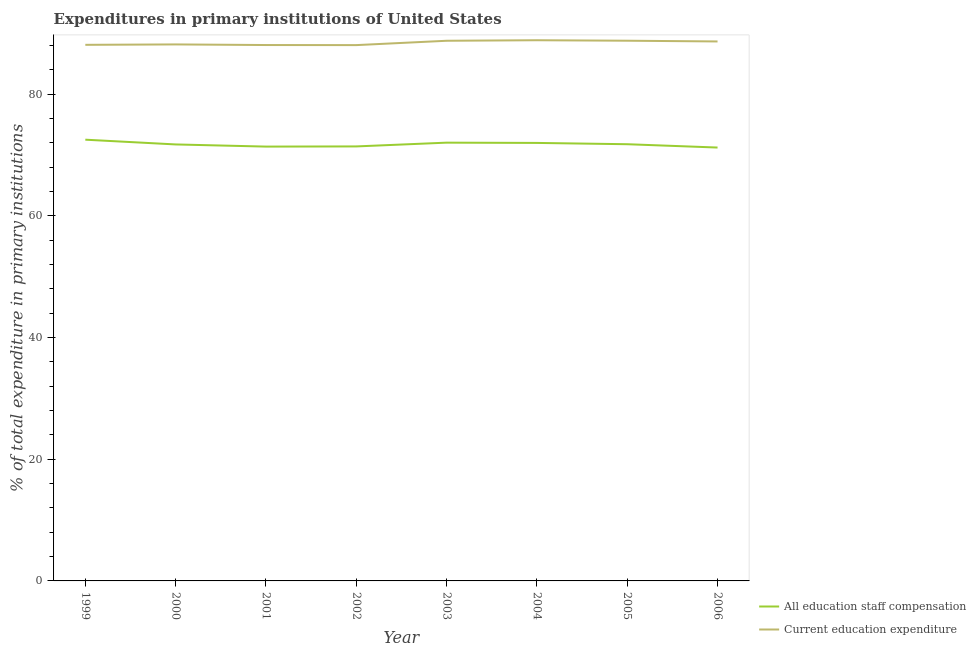How many different coloured lines are there?
Keep it short and to the point. 2. Does the line corresponding to expenditure in staff compensation intersect with the line corresponding to expenditure in education?
Ensure brevity in your answer.  No. What is the expenditure in education in 2004?
Offer a very short reply. 88.89. Across all years, what is the maximum expenditure in education?
Give a very brief answer. 88.89. Across all years, what is the minimum expenditure in education?
Offer a very short reply. 88.09. What is the total expenditure in education in the graph?
Provide a short and direct response. 707.7. What is the difference between the expenditure in education in 2000 and that in 2003?
Your response must be concise. -0.6. What is the difference between the expenditure in staff compensation in 2004 and the expenditure in education in 2000?
Provide a succinct answer. -16.19. What is the average expenditure in staff compensation per year?
Give a very brief answer. 71.78. In the year 2000, what is the difference between the expenditure in education and expenditure in staff compensation?
Provide a succinct answer. 16.44. In how many years, is the expenditure in education greater than 28 %?
Offer a terse response. 8. What is the ratio of the expenditure in education in 1999 to that in 2004?
Provide a short and direct response. 0.99. Is the expenditure in staff compensation in 1999 less than that in 2005?
Your answer should be very brief. No. What is the difference between the highest and the second highest expenditure in staff compensation?
Ensure brevity in your answer.  0.49. What is the difference between the highest and the lowest expenditure in education?
Your answer should be very brief. 0.8. In how many years, is the expenditure in education greater than the average expenditure in education taken over all years?
Offer a very short reply. 4. Is the sum of the expenditure in staff compensation in 1999 and 2006 greater than the maximum expenditure in education across all years?
Keep it short and to the point. Yes. Is the expenditure in education strictly greater than the expenditure in staff compensation over the years?
Your response must be concise. Yes. Is the expenditure in education strictly less than the expenditure in staff compensation over the years?
Keep it short and to the point. No. How many lines are there?
Your answer should be compact. 2. Does the graph contain grids?
Keep it short and to the point. No. Where does the legend appear in the graph?
Make the answer very short. Bottom right. How are the legend labels stacked?
Offer a very short reply. Vertical. What is the title of the graph?
Ensure brevity in your answer.  Expenditures in primary institutions of United States. What is the label or title of the Y-axis?
Provide a short and direct response. % of total expenditure in primary institutions. What is the % of total expenditure in primary institutions in All education staff compensation in 1999?
Offer a very short reply. 72.54. What is the % of total expenditure in primary institutions in Current education expenditure in 1999?
Make the answer very short. 88.13. What is the % of total expenditure in primary institutions of All education staff compensation in 2000?
Give a very brief answer. 71.76. What is the % of total expenditure in primary institutions in Current education expenditure in 2000?
Your answer should be very brief. 88.2. What is the % of total expenditure in primary institutions of All education staff compensation in 2001?
Ensure brevity in your answer.  71.4. What is the % of total expenditure in primary institutions in Current education expenditure in 2001?
Offer a terse response. 88.1. What is the % of total expenditure in primary institutions of All education staff compensation in 2002?
Make the answer very short. 71.43. What is the % of total expenditure in primary institutions in Current education expenditure in 2002?
Give a very brief answer. 88.09. What is the % of total expenditure in primary institutions in All education staff compensation in 2003?
Give a very brief answer. 72.05. What is the % of total expenditure in primary institutions of Current education expenditure in 2003?
Ensure brevity in your answer.  88.8. What is the % of total expenditure in primary institutions in All education staff compensation in 2004?
Provide a succinct answer. 72.01. What is the % of total expenditure in primary institutions of Current education expenditure in 2004?
Your answer should be compact. 88.89. What is the % of total expenditure in primary institutions of All education staff compensation in 2005?
Provide a short and direct response. 71.79. What is the % of total expenditure in primary institutions of Current education expenditure in 2005?
Offer a very short reply. 88.81. What is the % of total expenditure in primary institutions in All education staff compensation in 2006?
Provide a short and direct response. 71.25. What is the % of total expenditure in primary institutions of Current education expenditure in 2006?
Keep it short and to the point. 88.69. Across all years, what is the maximum % of total expenditure in primary institutions of All education staff compensation?
Ensure brevity in your answer.  72.54. Across all years, what is the maximum % of total expenditure in primary institutions in Current education expenditure?
Offer a terse response. 88.89. Across all years, what is the minimum % of total expenditure in primary institutions in All education staff compensation?
Your answer should be very brief. 71.25. Across all years, what is the minimum % of total expenditure in primary institutions in Current education expenditure?
Keep it short and to the point. 88.09. What is the total % of total expenditure in primary institutions of All education staff compensation in the graph?
Ensure brevity in your answer.  574.22. What is the total % of total expenditure in primary institutions in Current education expenditure in the graph?
Give a very brief answer. 707.7. What is the difference between the % of total expenditure in primary institutions of All education staff compensation in 1999 and that in 2000?
Offer a very short reply. 0.78. What is the difference between the % of total expenditure in primary institutions in Current education expenditure in 1999 and that in 2000?
Your answer should be compact. -0.07. What is the difference between the % of total expenditure in primary institutions in All education staff compensation in 1999 and that in 2001?
Provide a succinct answer. 1.13. What is the difference between the % of total expenditure in primary institutions in Current education expenditure in 1999 and that in 2001?
Your answer should be compact. 0.03. What is the difference between the % of total expenditure in primary institutions in All education staff compensation in 1999 and that in 2002?
Give a very brief answer. 1.11. What is the difference between the % of total expenditure in primary institutions of Current education expenditure in 1999 and that in 2002?
Provide a succinct answer. 0.05. What is the difference between the % of total expenditure in primary institutions of All education staff compensation in 1999 and that in 2003?
Keep it short and to the point. 0.49. What is the difference between the % of total expenditure in primary institutions of Current education expenditure in 1999 and that in 2003?
Offer a terse response. -0.67. What is the difference between the % of total expenditure in primary institutions in All education staff compensation in 1999 and that in 2004?
Provide a succinct answer. 0.53. What is the difference between the % of total expenditure in primary institutions in Current education expenditure in 1999 and that in 2004?
Offer a very short reply. -0.76. What is the difference between the % of total expenditure in primary institutions in All education staff compensation in 1999 and that in 2005?
Ensure brevity in your answer.  0.74. What is the difference between the % of total expenditure in primary institutions in Current education expenditure in 1999 and that in 2005?
Provide a succinct answer. -0.68. What is the difference between the % of total expenditure in primary institutions of All education staff compensation in 1999 and that in 2006?
Ensure brevity in your answer.  1.29. What is the difference between the % of total expenditure in primary institutions of Current education expenditure in 1999 and that in 2006?
Provide a short and direct response. -0.56. What is the difference between the % of total expenditure in primary institutions of All education staff compensation in 2000 and that in 2001?
Offer a terse response. 0.35. What is the difference between the % of total expenditure in primary institutions in Current education expenditure in 2000 and that in 2001?
Make the answer very short. 0.1. What is the difference between the % of total expenditure in primary institutions in All education staff compensation in 2000 and that in 2002?
Offer a terse response. 0.32. What is the difference between the % of total expenditure in primary institutions of Current education expenditure in 2000 and that in 2002?
Your response must be concise. 0.11. What is the difference between the % of total expenditure in primary institutions in All education staff compensation in 2000 and that in 2003?
Your answer should be compact. -0.3. What is the difference between the % of total expenditure in primary institutions in Current education expenditure in 2000 and that in 2003?
Your answer should be compact. -0.6. What is the difference between the % of total expenditure in primary institutions in All education staff compensation in 2000 and that in 2004?
Your answer should be very brief. -0.25. What is the difference between the % of total expenditure in primary institutions in Current education expenditure in 2000 and that in 2004?
Give a very brief answer. -0.69. What is the difference between the % of total expenditure in primary institutions in All education staff compensation in 2000 and that in 2005?
Offer a terse response. -0.04. What is the difference between the % of total expenditure in primary institutions in Current education expenditure in 2000 and that in 2005?
Keep it short and to the point. -0.61. What is the difference between the % of total expenditure in primary institutions of All education staff compensation in 2000 and that in 2006?
Provide a succinct answer. 0.51. What is the difference between the % of total expenditure in primary institutions of Current education expenditure in 2000 and that in 2006?
Keep it short and to the point. -0.49. What is the difference between the % of total expenditure in primary institutions in All education staff compensation in 2001 and that in 2002?
Your response must be concise. -0.03. What is the difference between the % of total expenditure in primary institutions in Current education expenditure in 2001 and that in 2002?
Keep it short and to the point. 0.01. What is the difference between the % of total expenditure in primary institutions in All education staff compensation in 2001 and that in 2003?
Give a very brief answer. -0.65. What is the difference between the % of total expenditure in primary institutions of Current education expenditure in 2001 and that in 2003?
Your response must be concise. -0.7. What is the difference between the % of total expenditure in primary institutions in All education staff compensation in 2001 and that in 2004?
Ensure brevity in your answer.  -0.6. What is the difference between the % of total expenditure in primary institutions in Current education expenditure in 2001 and that in 2004?
Your response must be concise. -0.79. What is the difference between the % of total expenditure in primary institutions in All education staff compensation in 2001 and that in 2005?
Provide a succinct answer. -0.39. What is the difference between the % of total expenditure in primary institutions of Current education expenditure in 2001 and that in 2005?
Your answer should be compact. -0.71. What is the difference between the % of total expenditure in primary institutions of All education staff compensation in 2001 and that in 2006?
Give a very brief answer. 0.16. What is the difference between the % of total expenditure in primary institutions of Current education expenditure in 2001 and that in 2006?
Give a very brief answer. -0.59. What is the difference between the % of total expenditure in primary institutions in All education staff compensation in 2002 and that in 2003?
Your response must be concise. -0.62. What is the difference between the % of total expenditure in primary institutions of Current education expenditure in 2002 and that in 2003?
Offer a terse response. -0.71. What is the difference between the % of total expenditure in primary institutions in All education staff compensation in 2002 and that in 2004?
Keep it short and to the point. -0.57. What is the difference between the % of total expenditure in primary institutions in Current education expenditure in 2002 and that in 2004?
Provide a short and direct response. -0.8. What is the difference between the % of total expenditure in primary institutions of All education staff compensation in 2002 and that in 2005?
Make the answer very short. -0.36. What is the difference between the % of total expenditure in primary institutions in Current education expenditure in 2002 and that in 2005?
Your answer should be very brief. -0.72. What is the difference between the % of total expenditure in primary institutions in All education staff compensation in 2002 and that in 2006?
Offer a terse response. 0.18. What is the difference between the % of total expenditure in primary institutions in Current education expenditure in 2002 and that in 2006?
Offer a very short reply. -0.6. What is the difference between the % of total expenditure in primary institutions in All education staff compensation in 2003 and that in 2004?
Ensure brevity in your answer.  0.04. What is the difference between the % of total expenditure in primary institutions of Current education expenditure in 2003 and that in 2004?
Ensure brevity in your answer.  -0.09. What is the difference between the % of total expenditure in primary institutions in All education staff compensation in 2003 and that in 2005?
Your answer should be compact. 0.26. What is the difference between the % of total expenditure in primary institutions in Current education expenditure in 2003 and that in 2005?
Your response must be concise. -0.01. What is the difference between the % of total expenditure in primary institutions in All education staff compensation in 2003 and that in 2006?
Provide a short and direct response. 0.8. What is the difference between the % of total expenditure in primary institutions in Current education expenditure in 2003 and that in 2006?
Ensure brevity in your answer.  0.11. What is the difference between the % of total expenditure in primary institutions of All education staff compensation in 2004 and that in 2005?
Your answer should be compact. 0.21. What is the difference between the % of total expenditure in primary institutions in Current education expenditure in 2004 and that in 2005?
Offer a very short reply. 0.08. What is the difference between the % of total expenditure in primary institutions in All education staff compensation in 2004 and that in 2006?
Your response must be concise. 0.76. What is the difference between the % of total expenditure in primary institutions in Current education expenditure in 2004 and that in 2006?
Keep it short and to the point. 0.2. What is the difference between the % of total expenditure in primary institutions in All education staff compensation in 2005 and that in 2006?
Provide a short and direct response. 0.55. What is the difference between the % of total expenditure in primary institutions of Current education expenditure in 2005 and that in 2006?
Your response must be concise. 0.12. What is the difference between the % of total expenditure in primary institutions in All education staff compensation in 1999 and the % of total expenditure in primary institutions in Current education expenditure in 2000?
Make the answer very short. -15.66. What is the difference between the % of total expenditure in primary institutions of All education staff compensation in 1999 and the % of total expenditure in primary institutions of Current education expenditure in 2001?
Provide a short and direct response. -15.56. What is the difference between the % of total expenditure in primary institutions of All education staff compensation in 1999 and the % of total expenditure in primary institutions of Current education expenditure in 2002?
Ensure brevity in your answer.  -15.55. What is the difference between the % of total expenditure in primary institutions of All education staff compensation in 1999 and the % of total expenditure in primary institutions of Current education expenditure in 2003?
Your answer should be compact. -16.26. What is the difference between the % of total expenditure in primary institutions in All education staff compensation in 1999 and the % of total expenditure in primary institutions in Current education expenditure in 2004?
Give a very brief answer. -16.35. What is the difference between the % of total expenditure in primary institutions in All education staff compensation in 1999 and the % of total expenditure in primary institutions in Current education expenditure in 2005?
Your answer should be very brief. -16.27. What is the difference between the % of total expenditure in primary institutions of All education staff compensation in 1999 and the % of total expenditure in primary institutions of Current education expenditure in 2006?
Ensure brevity in your answer.  -16.15. What is the difference between the % of total expenditure in primary institutions of All education staff compensation in 2000 and the % of total expenditure in primary institutions of Current education expenditure in 2001?
Provide a succinct answer. -16.34. What is the difference between the % of total expenditure in primary institutions in All education staff compensation in 2000 and the % of total expenditure in primary institutions in Current education expenditure in 2002?
Ensure brevity in your answer.  -16.33. What is the difference between the % of total expenditure in primary institutions of All education staff compensation in 2000 and the % of total expenditure in primary institutions of Current education expenditure in 2003?
Keep it short and to the point. -17.04. What is the difference between the % of total expenditure in primary institutions in All education staff compensation in 2000 and the % of total expenditure in primary institutions in Current education expenditure in 2004?
Provide a succinct answer. -17.13. What is the difference between the % of total expenditure in primary institutions in All education staff compensation in 2000 and the % of total expenditure in primary institutions in Current education expenditure in 2005?
Your answer should be compact. -17.05. What is the difference between the % of total expenditure in primary institutions in All education staff compensation in 2000 and the % of total expenditure in primary institutions in Current education expenditure in 2006?
Provide a short and direct response. -16.93. What is the difference between the % of total expenditure in primary institutions in All education staff compensation in 2001 and the % of total expenditure in primary institutions in Current education expenditure in 2002?
Provide a succinct answer. -16.68. What is the difference between the % of total expenditure in primary institutions in All education staff compensation in 2001 and the % of total expenditure in primary institutions in Current education expenditure in 2003?
Provide a short and direct response. -17.4. What is the difference between the % of total expenditure in primary institutions of All education staff compensation in 2001 and the % of total expenditure in primary institutions of Current education expenditure in 2004?
Make the answer very short. -17.48. What is the difference between the % of total expenditure in primary institutions of All education staff compensation in 2001 and the % of total expenditure in primary institutions of Current education expenditure in 2005?
Give a very brief answer. -17.4. What is the difference between the % of total expenditure in primary institutions in All education staff compensation in 2001 and the % of total expenditure in primary institutions in Current education expenditure in 2006?
Offer a terse response. -17.28. What is the difference between the % of total expenditure in primary institutions of All education staff compensation in 2002 and the % of total expenditure in primary institutions of Current education expenditure in 2003?
Your response must be concise. -17.37. What is the difference between the % of total expenditure in primary institutions in All education staff compensation in 2002 and the % of total expenditure in primary institutions in Current education expenditure in 2004?
Keep it short and to the point. -17.46. What is the difference between the % of total expenditure in primary institutions in All education staff compensation in 2002 and the % of total expenditure in primary institutions in Current education expenditure in 2005?
Provide a succinct answer. -17.38. What is the difference between the % of total expenditure in primary institutions in All education staff compensation in 2002 and the % of total expenditure in primary institutions in Current education expenditure in 2006?
Keep it short and to the point. -17.26. What is the difference between the % of total expenditure in primary institutions of All education staff compensation in 2003 and the % of total expenditure in primary institutions of Current education expenditure in 2004?
Ensure brevity in your answer.  -16.84. What is the difference between the % of total expenditure in primary institutions of All education staff compensation in 2003 and the % of total expenditure in primary institutions of Current education expenditure in 2005?
Give a very brief answer. -16.76. What is the difference between the % of total expenditure in primary institutions of All education staff compensation in 2003 and the % of total expenditure in primary institutions of Current education expenditure in 2006?
Provide a succinct answer. -16.64. What is the difference between the % of total expenditure in primary institutions in All education staff compensation in 2004 and the % of total expenditure in primary institutions in Current education expenditure in 2005?
Your answer should be compact. -16.8. What is the difference between the % of total expenditure in primary institutions of All education staff compensation in 2004 and the % of total expenditure in primary institutions of Current education expenditure in 2006?
Keep it short and to the point. -16.68. What is the difference between the % of total expenditure in primary institutions of All education staff compensation in 2005 and the % of total expenditure in primary institutions of Current education expenditure in 2006?
Ensure brevity in your answer.  -16.89. What is the average % of total expenditure in primary institutions of All education staff compensation per year?
Your response must be concise. 71.78. What is the average % of total expenditure in primary institutions of Current education expenditure per year?
Provide a short and direct response. 88.46. In the year 1999, what is the difference between the % of total expenditure in primary institutions of All education staff compensation and % of total expenditure in primary institutions of Current education expenditure?
Your answer should be very brief. -15.59. In the year 2000, what is the difference between the % of total expenditure in primary institutions in All education staff compensation and % of total expenditure in primary institutions in Current education expenditure?
Your response must be concise. -16.44. In the year 2001, what is the difference between the % of total expenditure in primary institutions of All education staff compensation and % of total expenditure in primary institutions of Current education expenditure?
Make the answer very short. -16.7. In the year 2002, what is the difference between the % of total expenditure in primary institutions of All education staff compensation and % of total expenditure in primary institutions of Current education expenditure?
Your answer should be very brief. -16.65. In the year 2003, what is the difference between the % of total expenditure in primary institutions in All education staff compensation and % of total expenditure in primary institutions in Current education expenditure?
Your answer should be very brief. -16.75. In the year 2004, what is the difference between the % of total expenditure in primary institutions of All education staff compensation and % of total expenditure in primary institutions of Current education expenditure?
Your answer should be compact. -16.88. In the year 2005, what is the difference between the % of total expenditure in primary institutions of All education staff compensation and % of total expenditure in primary institutions of Current education expenditure?
Give a very brief answer. -17.01. In the year 2006, what is the difference between the % of total expenditure in primary institutions in All education staff compensation and % of total expenditure in primary institutions in Current education expenditure?
Provide a succinct answer. -17.44. What is the ratio of the % of total expenditure in primary institutions of All education staff compensation in 1999 to that in 2000?
Give a very brief answer. 1.01. What is the ratio of the % of total expenditure in primary institutions in All education staff compensation in 1999 to that in 2001?
Your response must be concise. 1.02. What is the ratio of the % of total expenditure in primary institutions in All education staff compensation in 1999 to that in 2002?
Ensure brevity in your answer.  1.02. What is the ratio of the % of total expenditure in primary institutions in Current education expenditure in 1999 to that in 2002?
Give a very brief answer. 1. What is the ratio of the % of total expenditure in primary institutions of Current education expenditure in 1999 to that in 2003?
Your answer should be very brief. 0.99. What is the ratio of the % of total expenditure in primary institutions of All education staff compensation in 1999 to that in 2004?
Offer a terse response. 1.01. What is the ratio of the % of total expenditure in primary institutions of All education staff compensation in 1999 to that in 2005?
Give a very brief answer. 1.01. What is the ratio of the % of total expenditure in primary institutions in Current education expenditure in 1999 to that in 2005?
Provide a succinct answer. 0.99. What is the ratio of the % of total expenditure in primary institutions in All education staff compensation in 1999 to that in 2006?
Give a very brief answer. 1.02. What is the ratio of the % of total expenditure in primary institutions in Current education expenditure in 1999 to that in 2006?
Give a very brief answer. 0.99. What is the ratio of the % of total expenditure in primary institutions of All education staff compensation in 2000 to that in 2001?
Your answer should be very brief. 1. What is the ratio of the % of total expenditure in primary institutions of Current education expenditure in 2000 to that in 2003?
Offer a terse response. 0.99. What is the ratio of the % of total expenditure in primary institutions in All education staff compensation in 2000 to that in 2004?
Make the answer very short. 1. What is the ratio of the % of total expenditure in primary institutions in Current education expenditure in 2000 to that in 2004?
Provide a succinct answer. 0.99. What is the ratio of the % of total expenditure in primary institutions in All education staff compensation in 2000 to that in 2005?
Provide a short and direct response. 1. What is the ratio of the % of total expenditure in primary institutions of Current education expenditure in 2000 to that in 2005?
Ensure brevity in your answer.  0.99. What is the ratio of the % of total expenditure in primary institutions in All education staff compensation in 2000 to that in 2006?
Your answer should be very brief. 1.01. What is the ratio of the % of total expenditure in primary institutions in Current education expenditure in 2000 to that in 2006?
Keep it short and to the point. 0.99. What is the ratio of the % of total expenditure in primary institutions in All education staff compensation in 2001 to that in 2003?
Offer a very short reply. 0.99. What is the ratio of the % of total expenditure in primary institutions of Current education expenditure in 2001 to that in 2004?
Your response must be concise. 0.99. What is the ratio of the % of total expenditure in primary institutions in All education staff compensation in 2001 to that in 2005?
Offer a terse response. 0.99. What is the ratio of the % of total expenditure in primary institutions in Current education expenditure in 2001 to that in 2006?
Keep it short and to the point. 0.99. What is the ratio of the % of total expenditure in primary institutions of Current education expenditure in 2002 to that in 2003?
Keep it short and to the point. 0.99. What is the ratio of the % of total expenditure in primary institutions of All education staff compensation in 2002 to that in 2004?
Provide a succinct answer. 0.99. What is the ratio of the % of total expenditure in primary institutions in Current education expenditure in 2002 to that in 2006?
Offer a very short reply. 0.99. What is the ratio of the % of total expenditure in primary institutions in Current education expenditure in 2003 to that in 2004?
Provide a short and direct response. 1. What is the ratio of the % of total expenditure in primary institutions in All education staff compensation in 2003 to that in 2005?
Give a very brief answer. 1. What is the ratio of the % of total expenditure in primary institutions in All education staff compensation in 2003 to that in 2006?
Your answer should be very brief. 1.01. What is the ratio of the % of total expenditure in primary institutions of All education staff compensation in 2004 to that in 2005?
Give a very brief answer. 1. What is the ratio of the % of total expenditure in primary institutions of All education staff compensation in 2004 to that in 2006?
Provide a succinct answer. 1.01. What is the ratio of the % of total expenditure in primary institutions in All education staff compensation in 2005 to that in 2006?
Offer a very short reply. 1.01. What is the difference between the highest and the second highest % of total expenditure in primary institutions of All education staff compensation?
Offer a terse response. 0.49. What is the difference between the highest and the second highest % of total expenditure in primary institutions in Current education expenditure?
Ensure brevity in your answer.  0.08. What is the difference between the highest and the lowest % of total expenditure in primary institutions in All education staff compensation?
Offer a terse response. 1.29. What is the difference between the highest and the lowest % of total expenditure in primary institutions in Current education expenditure?
Provide a succinct answer. 0.8. 